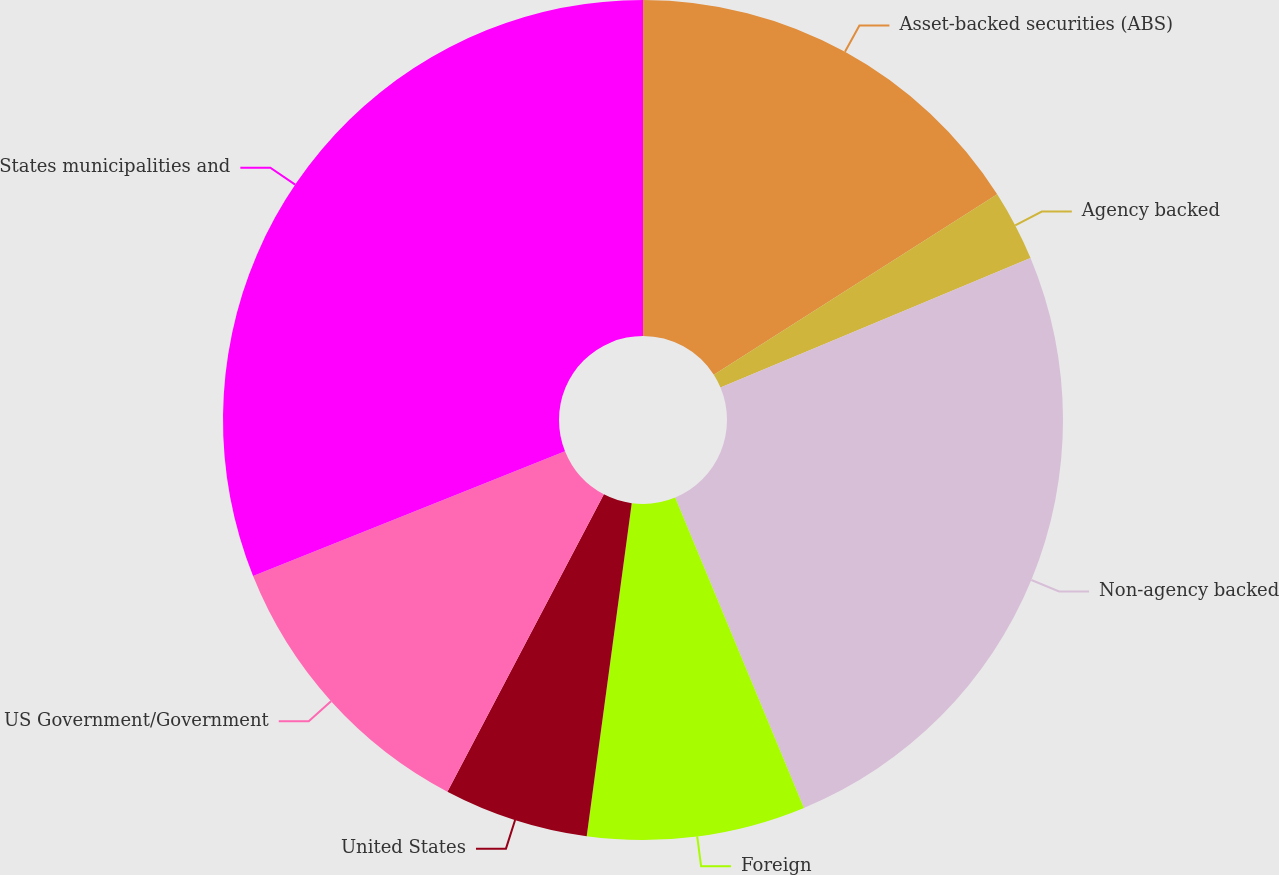<chart> <loc_0><loc_0><loc_500><loc_500><pie_chart><fcel>Asset-backed securities (ABS)<fcel>Agency backed<fcel>Non-agency backed<fcel>Foreign<fcel>United States<fcel>US Government/Government<fcel>States municipalities and<nl><fcel>15.97%<fcel>2.73%<fcel>25.04%<fcel>8.4%<fcel>5.57%<fcel>11.23%<fcel>31.06%<nl></chart> 